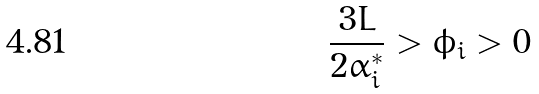<formula> <loc_0><loc_0><loc_500><loc_500>\frac { 3 L } { 2 \alpha _ { i } ^ { * } } > \phi _ { i } > 0</formula> 